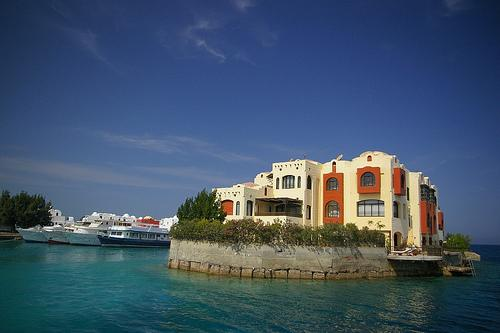What is the house near? Please explain your reasoning. water. The house is sitting close to the water of a beautiful bay. 